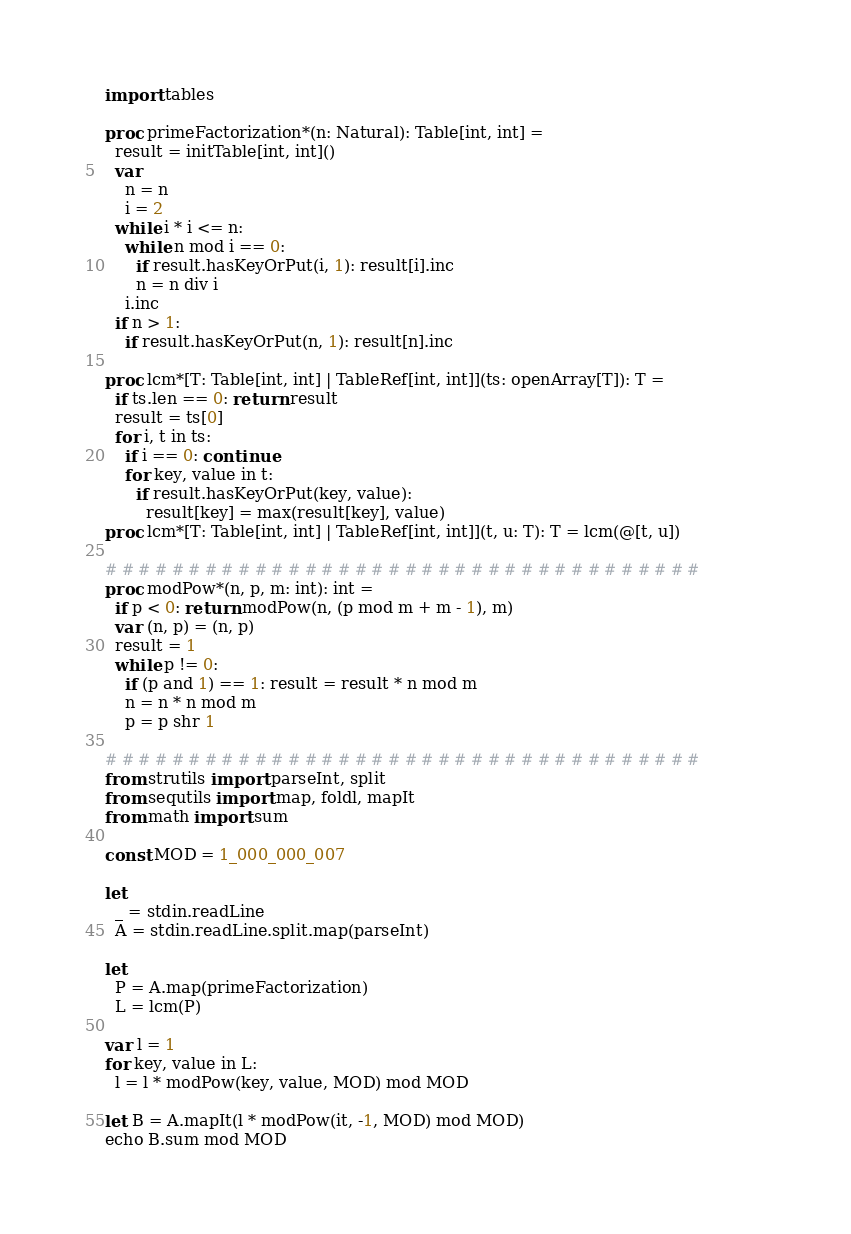Convert code to text. <code><loc_0><loc_0><loc_500><loc_500><_Nim_>import tables

proc primeFactorization*(n: Natural): Table[int, int] =
  result = initTable[int, int]()
  var
    n = n
    i = 2
  while i * i <= n:
    while n mod i == 0:
      if result.hasKeyOrPut(i, 1): result[i].inc
      n = n div i
    i.inc
  if n > 1:
    if result.hasKeyOrPut(n, 1): result[n].inc

proc lcm*[T: Table[int, int] | TableRef[int, int]](ts: openArray[T]): T =
  if ts.len == 0: return result
  result = ts[0]
  for i, t in ts:
    if i == 0: continue
    for key, value in t:
      if result.hasKeyOrPut(key, value):
        result[key] = max(result[key], value)
proc lcm*[T: Table[int, int] | TableRef[int, int]](t, u: T): T = lcm(@[t, u])

# # # # # # # # # # # # # # # # # # # # # # # # # # # # # # # # # # # #
proc modPow*(n, p, m: int): int =
  if p < 0: return modPow(n, (p mod m + m - 1), m)
  var (n, p) = (n, p)
  result = 1
  while p != 0:
    if (p and 1) == 1: result = result * n mod m
    n = n * n mod m
    p = p shr 1

# # # # # # # # # # # # # # # # # # # # # # # # # # # # # # # # # # # #
from strutils import parseInt, split
from sequtils import map, foldl, mapIt
from math import sum

const MOD = 1_000_000_007

let
  _ = stdin.readLine
  A = stdin.readLine.split.map(parseInt)

let
  P = A.map(primeFactorization)
  L = lcm(P)

var l = 1
for key, value in L:
  l = l * modPow(key, value, MOD) mod MOD

let B = A.mapIt(l * modPow(it, -1, MOD) mod MOD)
echo B.sum mod MOD
</code> 